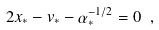<formula> <loc_0><loc_0><loc_500><loc_500>2 x _ { * } - v _ { * } - \alpha _ { * } ^ { - 1 / 2 } = 0 \ ,</formula> 